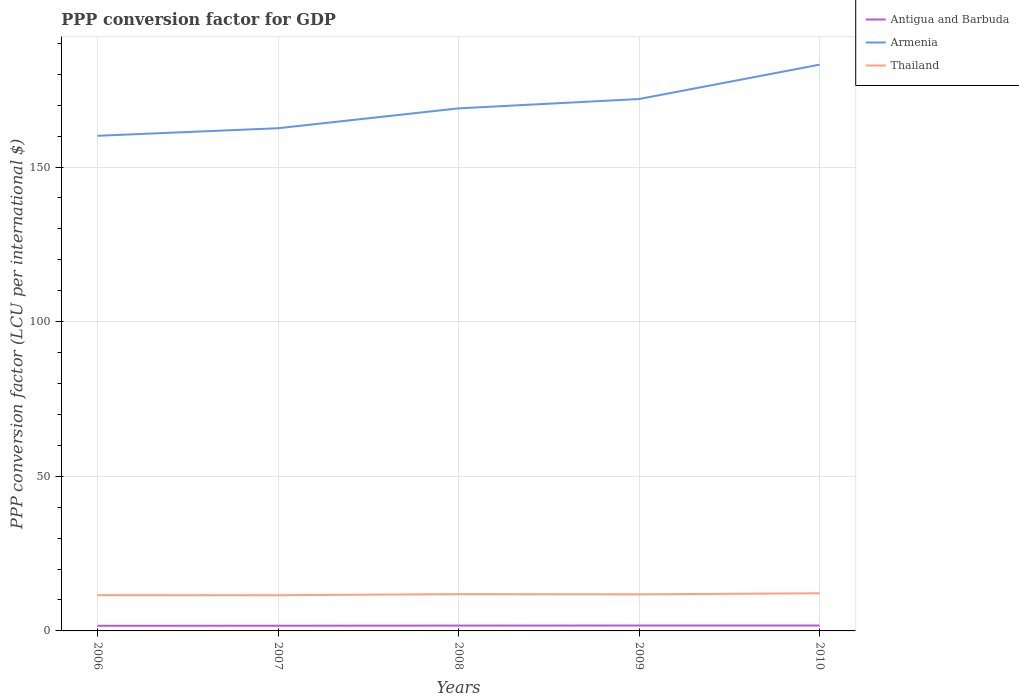Does the line corresponding to Armenia intersect with the line corresponding to Antigua and Barbuda?
Offer a terse response. No. Across all years, what is the maximum PPP conversion factor for GDP in Thailand?
Give a very brief answer. 11.54. In which year was the PPP conversion factor for GDP in Antigua and Barbuda maximum?
Offer a terse response. 2006. What is the total PPP conversion factor for GDP in Antigua and Barbuda in the graph?
Your response must be concise. -0.06. What is the difference between the highest and the second highest PPP conversion factor for GDP in Armenia?
Provide a short and direct response. 23.01. Is the PPP conversion factor for GDP in Armenia strictly greater than the PPP conversion factor for GDP in Thailand over the years?
Make the answer very short. No. How many years are there in the graph?
Provide a succinct answer. 5. What is the difference between two consecutive major ticks on the Y-axis?
Offer a terse response. 50. Where does the legend appear in the graph?
Your answer should be compact. Top right. How many legend labels are there?
Your response must be concise. 3. How are the legend labels stacked?
Offer a terse response. Vertical. What is the title of the graph?
Make the answer very short. PPP conversion factor for GDP. Does "Afghanistan" appear as one of the legend labels in the graph?
Your answer should be very brief. No. What is the label or title of the Y-axis?
Provide a short and direct response. PPP conversion factor (LCU per international $). What is the PPP conversion factor (LCU per international $) of Antigua and Barbuda in 2006?
Ensure brevity in your answer.  1.67. What is the PPP conversion factor (LCU per international $) of Armenia in 2006?
Keep it short and to the point. 160.11. What is the PPP conversion factor (LCU per international $) in Thailand in 2006?
Ensure brevity in your answer.  11.56. What is the PPP conversion factor (LCU per international $) of Antigua and Barbuda in 2007?
Make the answer very short. 1.68. What is the PPP conversion factor (LCU per international $) of Armenia in 2007?
Give a very brief answer. 162.56. What is the PPP conversion factor (LCU per international $) in Thailand in 2007?
Provide a succinct answer. 11.54. What is the PPP conversion factor (LCU per international $) in Antigua and Barbuda in 2008?
Offer a very short reply. 1.72. What is the PPP conversion factor (LCU per international $) of Armenia in 2008?
Offer a terse response. 168.98. What is the PPP conversion factor (LCU per international $) in Thailand in 2008?
Your answer should be compact. 11.9. What is the PPP conversion factor (LCU per international $) of Antigua and Barbuda in 2009?
Your answer should be compact. 1.74. What is the PPP conversion factor (LCU per international $) in Armenia in 2009?
Your answer should be compact. 171.99. What is the PPP conversion factor (LCU per international $) of Thailand in 2009?
Make the answer very short. 11.84. What is the PPP conversion factor (LCU per international $) in Antigua and Barbuda in 2010?
Offer a very short reply. 1.74. What is the PPP conversion factor (LCU per international $) of Armenia in 2010?
Provide a succinct answer. 183.12. What is the PPP conversion factor (LCU per international $) in Thailand in 2010?
Your response must be concise. 12.17. Across all years, what is the maximum PPP conversion factor (LCU per international $) of Antigua and Barbuda?
Ensure brevity in your answer.  1.74. Across all years, what is the maximum PPP conversion factor (LCU per international $) in Armenia?
Provide a succinct answer. 183.12. Across all years, what is the maximum PPP conversion factor (LCU per international $) of Thailand?
Your answer should be compact. 12.17. Across all years, what is the minimum PPP conversion factor (LCU per international $) in Antigua and Barbuda?
Ensure brevity in your answer.  1.67. Across all years, what is the minimum PPP conversion factor (LCU per international $) of Armenia?
Ensure brevity in your answer.  160.11. Across all years, what is the minimum PPP conversion factor (LCU per international $) in Thailand?
Offer a terse response. 11.54. What is the total PPP conversion factor (LCU per international $) of Antigua and Barbuda in the graph?
Make the answer very short. 8.56. What is the total PPP conversion factor (LCU per international $) in Armenia in the graph?
Offer a very short reply. 846.75. What is the total PPP conversion factor (LCU per international $) in Thailand in the graph?
Your answer should be very brief. 59.01. What is the difference between the PPP conversion factor (LCU per international $) in Antigua and Barbuda in 2006 and that in 2007?
Ensure brevity in your answer.  -0.02. What is the difference between the PPP conversion factor (LCU per international $) of Armenia in 2006 and that in 2007?
Provide a succinct answer. -2.45. What is the difference between the PPP conversion factor (LCU per international $) in Thailand in 2006 and that in 2007?
Your answer should be compact. 0.02. What is the difference between the PPP conversion factor (LCU per international $) in Antigua and Barbuda in 2006 and that in 2008?
Your response must be concise. -0.06. What is the difference between the PPP conversion factor (LCU per international $) of Armenia in 2006 and that in 2008?
Your answer should be very brief. -8.87. What is the difference between the PPP conversion factor (LCU per international $) of Thailand in 2006 and that in 2008?
Your response must be concise. -0.34. What is the difference between the PPP conversion factor (LCU per international $) of Antigua and Barbuda in 2006 and that in 2009?
Offer a very short reply. -0.08. What is the difference between the PPP conversion factor (LCU per international $) of Armenia in 2006 and that in 2009?
Make the answer very short. -11.89. What is the difference between the PPP conversion factor (LCU per international $) in Thailand in 2006 and that in 2009?
Keep it short and to the point. -0.27. What is the difference between the PPP conversion factor (LCU per international $) of Antigua and Barbuda in 2006 and that in 2010?
Offer a terse response. -0.08. What is the difference between the PPP conversion factor (LCU per international $) in Armenia in 2006 and that in 2010?
Provide a succinct answer. -23.01. What is the difference between the PPP conversion factor (LCU per international $) of Thailand in 2006 and that in 2010?
Offer a terse response. -0.61. What is the difference between the PPP conversion factor (LCU per international $) in Antigua and Barbuda in 2007 and that in 2008?
Offer a terse response. -0.04. What is the difference between the PPP conversion factor (LCU per international $) in Armenia in 2007 and that in 2008?
Your answer should be very brief. -6.42. What is the difference between the PPP conversion factor (LCU per international $) of Thailand in 2007 and that in 2008?
Give a very brief answer. -0.36. What is the difference between the PPP conversion factor (LCU per international $) of Antigua and Barbuda in 2007 and that in 2009?
Offer a terse response. -0.06. What is the difference between the PPP conversion factor (LCU per international $) of Armenia in 2007 and that in 2009?
Make the answer very short. -9.44. What is the difference between the PPP conversion factor (LCU per international $) of Thailand in 2007 and that in 2009?
Keep it short and to the point. -0.29. What is the difference between the PPP conversion factor (LCU per international $) of Antigua and Barbuda in 2007 and that in 2010?
Offer a terse response. -0.06. What is the difference between the PPP conversion factor (LCU per international $) in Armenia in 2007 and that in 2010?
Offer a terse response. -20.56. What is the difference between the PPP conversion factor (LCU per international $) of Thailand in 2007 and that in 2010?
Make the answer very short. -0.63. What is the difference between the PPP conversion factor (LCU per international $) in Antigua and Barbuda in 2008 and that in 2009?
Provide a short and direct response. -0.02. What is the difference between the PPP conversion factor (LCU per international $) in Armenia in 2008 and that in 2009?
Ensure brevity in your answer.  -3.01. What is the difference between the PPP conversion factor (LCU per international $) in Thailand in 2008 and that in 2009?
Your response must be concise. 0.07. What is the difference between the PPP conversion factor (LCU per international $) of Antigua and Barbuda in 2008 and that in 2010?
Give a very brief answer. -0.02. What is the difference between the PPP conversion factor (LCU per international $) in Armenia in 2008 and that in 2010?
Make the answer very short. -14.14. What is the difference between the PPP conversion factor (LCU per international $) in Thailand in 2008 and that in 2010?
Offer a terse response. -0.27. What is the difference between the PPP conversion factor (LCU per international $) of Antigua and Barbuda in 2009 and that in 2010?
Offer a very short reply. -0. What is the difference between the PPP conversion factor (LCU per international $) of Armenia in 2009 and that in 2010?
Offer a very short reply. -11.13. What is the difference between the PPP conversion factor (LCU per international $) in Thailand in 2009 and that in 2010?
Keep it short and to the point. -0.33. What is the difference between the PPP conversion factor (LCU per international $) of Antigua and Barbuda in 2006 and the PPP conversion factor (LCU per international $) of Armenia in 2007?
Ensure brevity in your answer.  -160.89. What is the difference between the PPP conversion factor (LCU per international $) of Antigua and Barbuda in 2006 and the PPP conversion factor (LCU per international $) of Thailand in 2007?
Keep it short and to the point. -9.88. What is the difference between the PPP conversion factor (LCU per international $) of Armenia in 2006 and the PPP conversion factor (LCU per international $) of Thailand in 2007?
Ensure brevity in your answer.  148.56. What is the difference between the PPP conversion factor (LCU per international $) in Antigua and Barbuda in 2006 and the PPP conversion factor (LCU per international $) in Armenia in 2008?
Ensure brevity in your answer.  -167.31. What is the difference between the PPP conversion factor (LCU per international $) in Antigua and Barbuda in 2006 and the PPP conversion factor (LCU per international $) in Thailand in 2008?
Keep it short and to the point. -10.24. What is the difference between the PPP conversion factor (LCU per international $) in Armenia in 2006 and the PPP conversion factor (LCU per international $) in Thailand in 2008?
Your response must be concise. 148.2. What is the difference between the PPP conversion factor (LCU per international $) in Antigua and Barbuda in 2006 and the PPP conversion factor (LCU per international $) in Armenia in 2009?
Give a very brief answer. -170.33. What is the difference between the PPP conversion factor (LCU per international $) of Antigua and Barbuda in 2006 and the PPP conversion factor (LCU per international $) of Thailand in 2009?
Your answer should be very brief. -10.17. What is the difference between the PPP conversion factor (LCU per international $) of Armenia in 2006 and the PPP conversion factor (LCU per international $) of Thailand in 2009?
Offer a very short reply. 148.27. What is the difference between the PPP conversion factor (LCU per international $) in Antigua and Barbuda in 2006 and the PPP conversion factor (LCU per international $) in Armenia in 2010?
Offer a terse response. -181.45. What is the difference between the PPP conversion factor (LCU per international $) in Antigua and Barbuda in 2006 and the PPP conversion factor (LCU per international $) in Thailand in 2010?
Offer a very short reply. -10.5. What is the difference between the PPP conversion factor (LCU per international $) of Armenia in 2006 and the PPP conversion factor (LCU per international $) of Thailand in 2010?
Your answer should be very brief. 147.94. What is the difference between the PPP conversion factor (LCU per international $) in Antigua and Barbuda in 2007 and the PPP conversion factor (LCU per international $) in Armenia in 2008?
Ensure brevity in your answer.  -167.29. What is the difference between the PPP conversion factor (LCU per international $) of Antigua and Barbuda in 2007 and the PPP conversion factor (LCU per international $) of Thailand in 2008?
Provide a short and direct response. -10.22. What is the difference between the PPP conversion factor (LCU per international $) in Armenia in 2007 and the PPP conversion factor (LCU per international $) in Thailand in 2008?
Your answer should be compact. 150.65. What is the difference between the PPP conversion factor (LCU per international $) of Antigua and Barbuda in 2007 and the PPP conversion factor (LCU per international $) of Armenia in 2009?
Ensure brevity in your answer.  -170.31. What is the difference between the PPP conversion factor (LCU per international $) in Antigua and Barbuda in 2007 and the PPP conversion factor (LCU per international $) in Thailand in 2009?
Your response must be concise. -10.15. What is the difference between the PPP conversion factor (LCU per international $) of Armenia in 2007 and the PPP conversion factor (LCU per international $) of Thailand in 2009?
Provide a succinct answer. 150.72. What is the difference between the PPP conversion factor (LCU per international $) of Antigua and Barbuda in 2007 and the PPP conversion factor (LCU per international $) of Armenia in 2010?
Make the answer very short. -181.43. What is the difference between the PPP conversion factor (LCU per international $) in Antigua and Barbuda in 2007 and the PPP conversion factor (LCU per international $) in Thailand in 2010?
Ensure brevity in your answer.  -10.49. What is the difference between the PPP conversion factor (LCU per international $) in Armenia in 2007 and the PPP conversion factor (LCU per international $) in Thailand in 2010?
Give a very brief answer. 150.39. What is the difference between the PPP conversion factor (LCU per international $) in Antigua and Barbuda in 2008 and the PPP conversion factor (LCU per international $) in Armenia in 2009?
Your answer should be compact. -170.27. What is the difference between the PPP conversion factor (LCU per international $) of Antigua and Barbuda in 2008 and the PPP conversion factor (LCU per international $) of Thailand in 2009?
Your answer should be very brief. -10.11. What is the difference between the PPP conversion factor (LCU per international $) in Armenia in 2008 and the PPP conversion factor (LCU per international $) in Thailand in 2009?
Keep it short and to the point. 157.14. What is the difference between the PPP conversion factor (LCU per international $) in Antigua and Barbuda in 2008 and the PPP conversion factor (LCU per international $) in Armenia in 2010?
Offer a very short reply. -181.39. What is the difference between the PPP conversion factor (LCU per international $) in Antigua and Barbuda in 2008 and the PPP conversion factor (LCU per international $) in Thailand in 2010?
Your response must be concise. -10.45. What is the difference between the PPP conversion factor (LCU per international $) of Armenia in 2008 and the PPP conversion factor (LCU per international $) of Thailand in 2010?
Your answer should be compact. 156.81. What is the difference between the PPP conversion factor (LCU per international $) of Antigua and Barbuda in 2009 and the PPP conversion factor (LCU per international $) of Armenia in 2010?
Offer a terse response. -181.38. What is the difference between the PPP conversion factor (LCU per international $) of Antigua and Barbuda in 2009 and the PPP conversion factor (LCU per international $) of Thailand in 2010?
Give a very brief answer. -10.43. What is the difference between the PPP conversion factor (LCU per international $) of Armenia in 2009 and the PPP conversion factor (LCU per international $) of Thailand in 2010?
Offer a terse response. 159.82. What is the average PPP conversion factor (LCU per international $) of Antigua and Barbuda per year?
Make the answer very short. 1.71. What is the average PPP conversion factor (LCU per international $) of Armenia per year?
Your response must be concise. 169.35. What is the average PPP conversion factor (LCU per international $) in Thailand per year?
Provide a succinct answer. 11.8. In the year 2006, what is the difference between the PPP conversion factor (LCU per international $) of Antigua and Barbuda and PPP conversion factor (LCU per international $) of Armenia?
Your answer should be compact. -158.44. In the year 2006, what is the difference between the PPP conversion factor (LCU per international $) of Antigua and Barbuda and PPP conversion factor (LCU per international $) of Thailand?
Provide a succinct answer. -9.9. In the year 2006, what is the difference between the PPP conversion factor (LCU per international $) of Armenia and PPP conversion factor (LCU per international $) of Thailand?
Make the answer very short. 148.54. In the year 2007, what is the difference between the PPP conversion factor (LCU per international $) of Antigua and Barbuda and PPP conversion factor (LCU per international $) of Armenia?
Give a very brief answer. -160.87. In the year 2007, what is the difference between the PPP conversion factor (LCU per international $) of Antigua and Barbuda and PPP conversion factor (LCU per international $) of Thailand?
Your answer should be very brief. -9.86. In the year 2007, what is the difference between the PPP conversion factor (LCU per international $) in Armenia and PPP conversion factor (LCU per international $) in Thailand?
Keep it short and to the point. 151.01. In the year 2008, what is the difference between the PPP conversion factor (LCU per international $) of Antigua and Barbuda and PPP conversion factor (LCU per international $) of Armenia?
Offer a very short reply. -167.25. In the year 2008, what is the difference between the PPP conversion factor (LCU per international $) in Antigua and Barbuda and PPP conversion factor (LCU per international $) in Thailand?
Provide a succinct answer. -10.18. In the year 2008, what is the difference between the PPP conversion factor (LCU per international $) of Armenia and PPP conversion factor (LCU per international $) of Thailand?
Keep it short and to the point. 157.08. In the year 2009, what is the difference between the PPP conversion factor (LCU per international $) of Antigua and Barbuda and PPP conversion factor (LCU per international $) of Armenia?
Provide a short and direct response. -170.25. In the year 2009, what is the difference between the PPP conversion factor (LCU per international $) in Antigua and Barbuda and PPP conversion factor (LCU per international $) in Thailand?
Make the answer very short. -10.09. In the year 2009, what is the difference between the PPP conversion factor (LCU per international $) of Armenia and PPP conversion factor (LCU per international $) of Thailand?
Offer a terse response. 160.16. In the year 2010, what is the difference between the PPP conversion factor (LCU per international $) in Antigua and Barbuda and PPP conversion factor (LCU per international $) in Armenia?
Offer a terse response. -181.37. In the year 2010, what is the difference between the PPP conversion factor (LCU per international $) in Antigua and Barbuda and PPP conversion factor (LCU per international $) in Thailand?
Keep it short and to the point. -10.43. In the year 2010, what is the difference between the PPP conversion factor (LCU per international $) of Armenia and PPP conversion factor (LCU per international $) of Thailand?
Make the answer very short. 170.95. What is the ratio of the PPP conversion factor (LCU per international $) of Armenia in 2006 to that in 2007?
Give a very brief answer. 0.98. What is the ratio of the PPP conversion factor (LCU per international $) in Thailand in 2006 to that in 2007?
Your response must be concise. 1. What is the ratio of the PPP conversion factor (LCU per international $) of Antigua and Barbuda in 2006 to that in 2008?
Provide a short and direct response. 0.97. What is the ratio of the PPP conversion factor (LCU per international $) of Armenia in 2006 to that in 2008?
Ensure brevity in your answer.  0.95. What is the ratio of the PPP conversion factor (LCU per international $) of Thailand in 2006 to that in 2008?
Your answer should be very brief. 0.97. What is the ratio of the PPP conversion factor (LCU per international $) of Antigua and Barbuda in 2006 to that in 2009?
Keep it short and to the point. 0.96. What is the ratio of the PPP conversion factor (LCU per international $) in Armenia in 2006 to that in 2009?
Keep it short and to the point. 0.93. What is the ratio of the PPP conversion factor (LCU per international $) of Thailand in 2006 to that in 2009?
Your answer should be compact. 0.98. What is the ratio of the PPP conversion factor (LCU per international $) of Antigua and Barbuda in 2006 to that in 2010?
Your answer should be very brief. 0.96. What is the ratio of the PPP conversion factor (LCU per international $) of Armenia in 2006 to that in 2010?
Your response must be concise. 0.87. What is the ratio of the PPP conversion factor (LCU per international $) of Thailand in 2006 to that in 2010?
Your response must be concise. 0.95. What is the ratio of the PPP conversion factor (LCU per international $) in Antigua and Barbuda in 2007 to that in 2008?
Offer a very short reply. 0.98. What is the ratio of the PPP conversion factor (LCU per international $) of Armenia in 2007 to that in 2008?
Make the answer very short. 0.96. What is the ratio of the PPP conversion factor (LCU per international $) of Thailand in 2007 to that in 2008?
Provide a succinct answer. 0.97. What is the ratio of the PPP conversion factor (LCU per international $) in Antigua and Barbuda in 2007 to that in 2009?
Give a very brief answer. 0.97. What is the ratio of the PPP conversion factor (LCU per international $) of Armenia in 2007 to that in 2009?
Your response must be concise. 0.95. What is the ratio of the PPP conversion factor (LCU per international $) of Thailand in 2007 to that in 2009?
Your response must be concise. 0.98. What is the ratio of the PPP conversion factor (LCU per international $) of Antigua and Barbuda in 2007 to that in 2010?
Make the answer very short. 0.97. What is the ratio of the PPP conversion factor (LCU per international $) of Armenia in 2007 to that in 2010?
Your answer should be compact. 0.89. What is the ratio of the PPP conversion factor (LCU per international $) of Thailand in 2007 to that in 2010?
Your answer should be compact. 0.95. What is the ratio of the PPP conversion factor (LCU per international $) of Armenia in 2008 to that in 2009?
Give a very brief answer. 0.98. What is the ratio of the PPP conversion factor (LCU per international $) in Thailand in 2008 to that in 2009?
Ensure brevity in your answer.  1.01. What is the ratio of the PPP conversion factor (LCU per international $) of Antigua and Barbuda in 2008 to that in 2010?
Provide a succinct answer. 0.99. What is the ratio of the PPP conversion factor (LCU per international $) in Armenia in 2008 to that in 2010?
Provide a succinct answer. 0.92. What is the ratio of the PPP conversion factor (LCU per international $) of Armenia in 2009 to that in 2010?
Ensure brevity in your answer.  0.94. What is the ratio of the PPP conversion factor (LCU per international $) in Thailand in 2009 to that in 2010?
Your answer should be very brief. 0.97. What is the difference between the highest and the second highest PPP conversion factor (LCU per international $) of Antigua and Barbuda?
Your answer should be compact. 0. What is the difference between the highest and the second highest PPP conversion factor (LCU per international $) in Armenia?
Offer a very short reply. 11.13. What is the difference between the highest and the second highest PPP conversion factor (LCU per international $) in Thailand?
Keep it short and to the point. 0.27. What is the difference between the highest and the lowest PPP conversion factor (LCU per international $) of Antigua and Barbuda?
Keep it short and to the point. 0.08. What is the difference between the highest and the lowest PPP conversion factor (LCU per international $) of Armenia?
Your response must be concise. 23.01. What is the difference between the highest and the lowest PPP conversion factor (LCU per international $) of Thailand?
Provide a succinct answer. 0.63. 